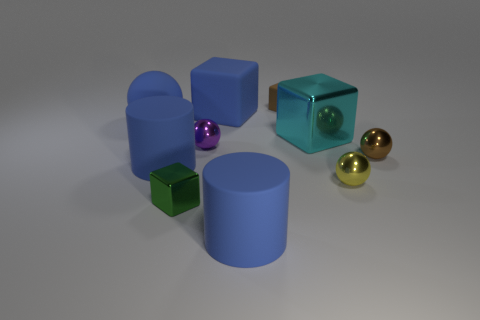Subtract all tiny metal balls. How many balls are left? 1 Subtract all green blocks. How many blocks are left? 3 Subtract 1 cylinders. How many cylinders are left? 1 Subtract all cubes. How many objects are left? 6 Subtract all red balls. How many green blocks are left? 1 Subtract all small purple metal objects. Subtract all brown metal balls. How many objects are left? 8 Add 8 small purple spheres. How many small purple spheres are left? 9 Add 3 large blue objects. How many large blue objects exist? 7 Subtract 1 blue cubes. How many objects are left? 9 Subtract all green spheres. Subtract all red blocks. How many spheres are left? 4 